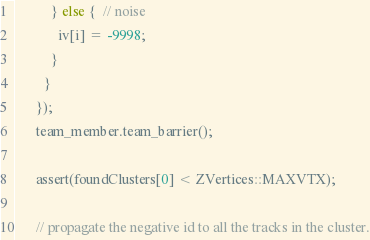<code> <loc_0><loc_0><loc_500><loc_500><_C_>          } else {  // noise
            iv[i] = -9998;
          }
        }
      });
      team_member.team_barrier();

      assert(foundClusters[0] < ZVertices::MAXVTX);

      // propagate the negative id to all the tracks in the cluster.</code> 